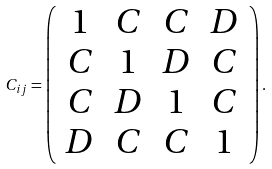Convert formula to latex. <formula><loc_0><loc_0><loc_500><loc_500>C _ { i j } = \left ( \begin{array} { c c c c } 1 & C & C & D \\ C & 1 & D & C \\ C & D & 1 & C \\ D & C & C & 1 \end{array} \right ) .</formula> 